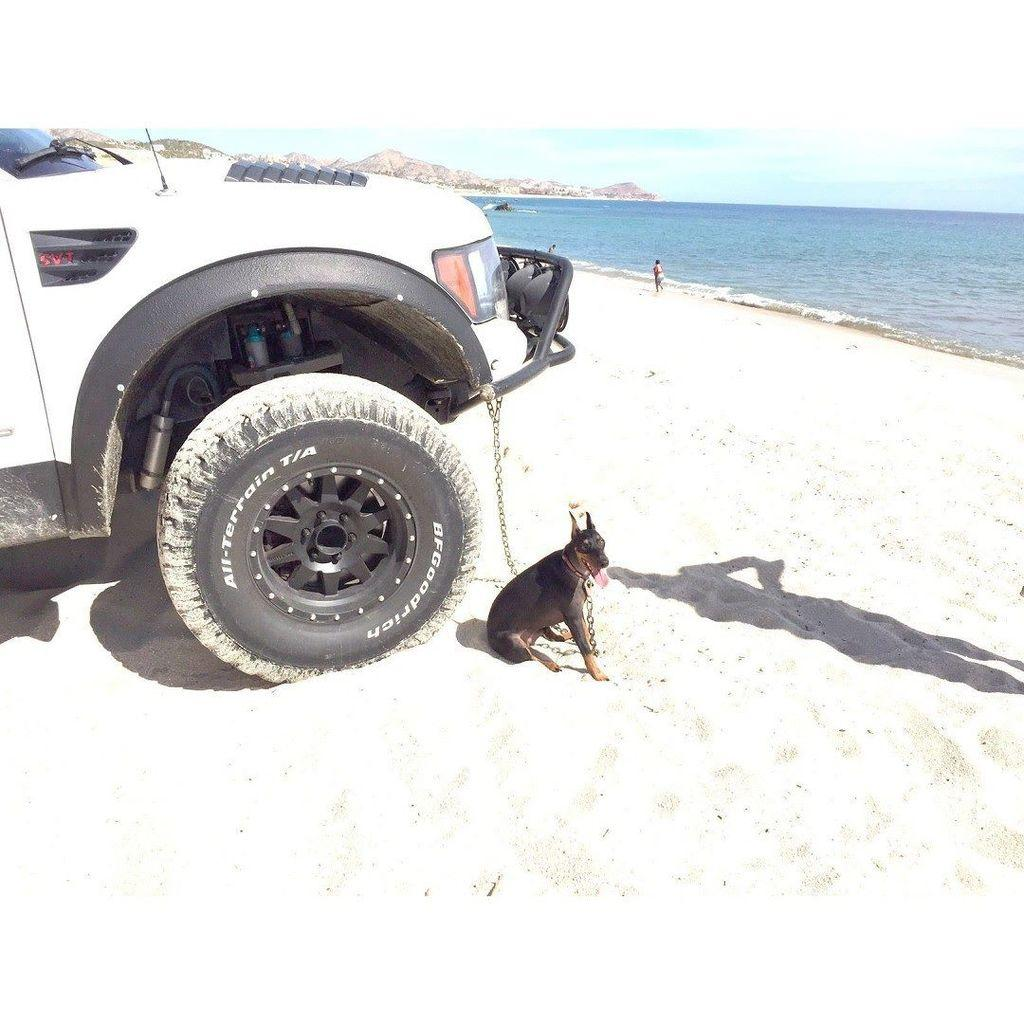What animal can be seen in the image? There is a dog in the image. Where is the dog located? The dog is sitting on the seashore. How is the dog connected to the motor vehicle? The dog is tied to a motor vehicle. What can be seen in the sky in the image? Clouds are present in the sky. What type of natural landscape is visible in the background of the image? There are hills in the background of the image. Can you describe the person standing on the seashore in the background? There is a person standing on the seashore in the background. What body of water is visible in the image? The sea is visible in the background of the image. What type of music can be heard coming from the dog in the image? There is no music coming from the dog in the image; it is a dog sitting on the seashore. 